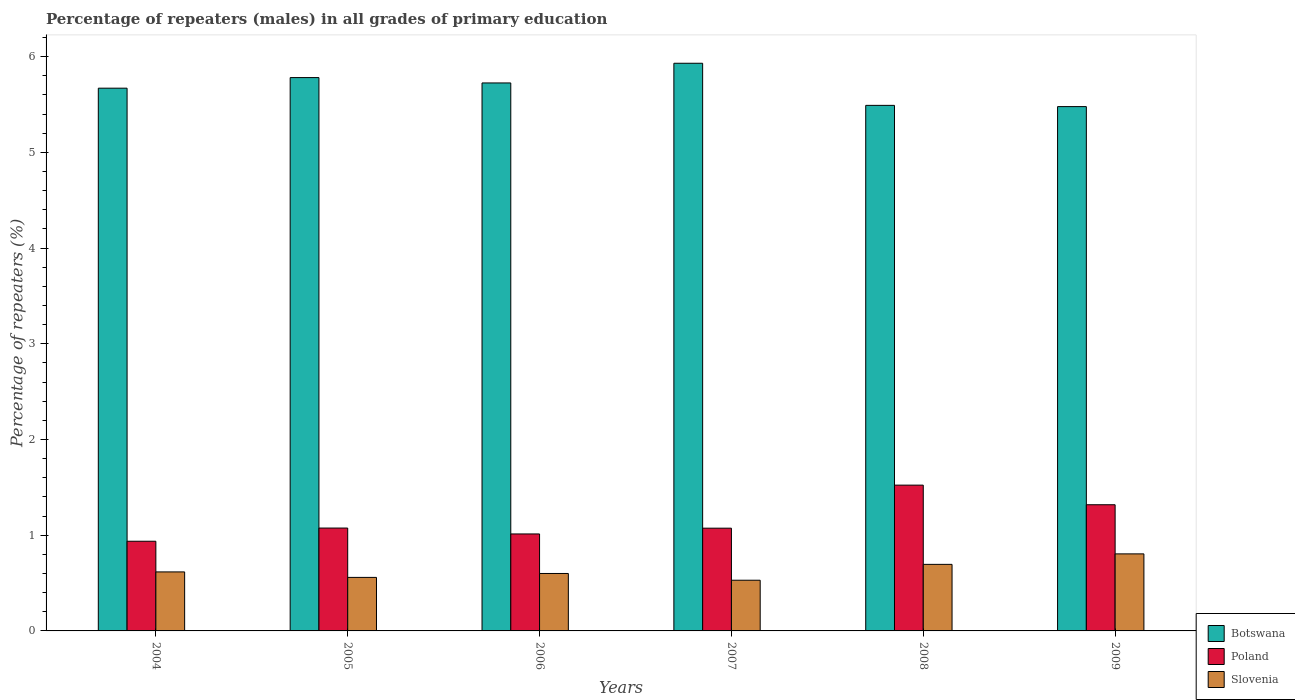How many different coloured bars are there?
Your response must be concise. 3. How many groups of bars are there?
Provide a succinct answer. 6. Are the number of bars on each tick of the X-axis equal?
Provide a succinct answer. Yes. How many bars are there on the 5th tick from the left?
Give a very brief answer. 3. How many bars are there on the 2nd tick from the right?
Offer a very short reply. 3. What is the label of the 1st group of bars from the left?
Ensure brevity in your answer.  2004. What is the percentage of repeaters (males) in Botswana in 2007?
Ensure brevity in your answer.  5.93. Across all years, what is the maximum percentage of repeaters (males) in Botswana?
Make the answer very short. 5.93. Across all years, what is the minimum percentage of repeaters (males) in Slovenia?
Your answer should be compact. 0.53. In which year was the percentage of repeaters (males) in Poland maximum?
Your answer should be compact. 2008. In which year was the percentage of repeaters (males) in Poland minimum?
Ensure brevity in your answer.  2004. What is the total percentage of repeaters (males) in Poland in the graph?
Your response must be concise. 6.94. What is the difference between the percentage of repeaters (males) in Botswana in 2004 and that in 2006?
Your answer should be very brief. -0.05. What is the difference between the percentage of repeaters (males) in Poland in 2009 and the percentage of repeaters (males) in Slovenia in 2006?
Make the answer very short. 0.72. What is the average percentage of repeaters (males) in Poland per year?
Your response must be concise. 1.16. In the year 2005, what is the difference between the percentage of repeaters (males) in Poland and percentage of repeaters (males) in Slovenia?
Offer a very short reply. 0.52. What is the ratio of the percentage of repeaters (males) in Slovenia in 2004 to that in 2009?
Give a very brief answer. 0.77. Is the percentage of repeaters (males) in Poland in 2007 less than that in 2008?
Ensure brevity in your answer.  Yes. What is the difference between the highest and the second highest percentage of repeaters (males) in Botswana?
Give a very brief answer. 0.15. What is the difference between the highest and the lowest percentage of repeaters (males) in Botswana?
Make the answer very short. 0.45. What does the 3rd bar from the left in 2007 represents?
Provide a succinct answer. Slovenia. What does the 3rd bar from the right in 2009 represents?
Offer a terse response. Botswana. Is it the case that in every year, the sum of the percentage of repeaters (males) in Slovenia and percentage of repeaters (males) in Poland is greater than the percentage of repeaters (males) in Botswana?
Your response must be concise. No. Are all the bars in the graph horizontal?
Ensure brevity in your answer.  No. How many years are there in the graph?
Offer a very short reply. 6. Does the graph contain any zero values?
Give a very brief answer. No. Does the graph contain grids?
Your answer should be compact. No. How many legend labels are there?
Ensure brevity in your answer.  3. What is the title of the graph?
Offer a very short reply. Percentage of repeaters (males) in all grades of primary education. Does "Chile" appear as one of the legend labels in the graph?
Your answer should be very brief. No. What is the label or title of the X-axis?
Offer a very short reply. Years. What is the label or title of the Y-axis?
Your answer should be very brief. Percentage of repeaters (%). What is the Percentage of repeaters (%) in Botswana in 2004?
Offer a terse response. 5.67. What is the Percentage of repeaters (%) in Poland in 2004?
Give a very brief answer. 0.94. What is the Percentage of repeaters (%) of Slovenia in 2004?
Your response must be concise. 0.62. What is the Percentage of repeaters (%) of Botswana in 2005?
Offer a very short reply. 5.78. What is the Percentage of repeaters (%) of Poland in 2005?
Provide a short and direct response. 1.07. What is the Percentage of repeaters (%) of Slovenia in 2005?
Provide a succinct answer. 0.56. What is the Percentage of repeaters (%) of Botswana in 2006?
Your response must be concise. 5.72. What is the Percentage of repeaters (%) in Poland in 2006?
Your response must be concise. 1.01. What is the Percentage of repeaters (%) of Slovenia in 2006?
Your response must be concise. 0.6. What is the Percentage of repeaters (%) of Botswana in 2007?
Your answer should be compact. 5.93. What is the Percentage of repeaters (%) in Poland in 2007?
Provide a succinct answer. 1.07. What is the Percentage of repeaters (%) of Slovenia in 2007?
Provide a short and direct response. 0.53. What is the Percentage of repeaters (%) of Botswana in 2008?
Provide a succinct answer. 5.49. What is the Percentage of repeaters (%) in Poland in 2008?
Keep it short and to the point. 1.52. What is the Percentage of repeaters (%) in Slovenia in 2008?
Provide a succinct answer. 0.7. What is the Percentage of repeaters (%) of Botswana in 2009?
Give a very brief answer. 5.48. What is the Percentage of repeaters (%) of Poland in 2009?
Keep it short and to the point. 1.32. What is the Percentage of repeaters (%) of Slovenia in 2009?
Give a very brief answer. 0.8. Across all years, what is the maximum Percentage of repeaters (%) of Botswana?
Keep it short and to the point. 5.93. Across all years, what is the maximum Percentage of repeaters (%) of Poland?
Provide a succinct answer. 1.52. Across all years, what is the maximum Percentage of repeaters (%) of Slovenia?
Your answer should be compact. 0.8. Across all years, what is the minimum Percentage of repeaters (%) of Botswana?
Offer a terse response. 5.48. Across all years, what is the minimum Percentage of repeaters (%) of Poland?
Your response must be concise. 0.94. Across all years, what is the minimum Percentage of repeaters (%) in Slovenia?
Your answer should be very brief. 0.53. What is the total Percentage of repeaters (%) of Botswana in the graph?
Offer a very short reply. 34.07. What is the total Percentage of repeaters (%) of Poland in the graph?
Your answer should be very brief. 6.94. What is the total Percentage of repeaters (%) of Slovenia in the graph?
Ensure brevity in your answer.  3.81. What is the difference between the Percentage of repeaters (%) of Botswana in 2004 and that in 2005?
Your answer should be compact. -0.11. What is the difference between the Percentage of repeaters (%) in Poland in 2004 and that in 2005?
Make the answer very short. -0.14. What is the difference between the Percentage of repeaters (%) in Slovenia in 2004 and that in 2005?
Provide a succinct answer. 0.06. What is the difference between the Percentage of repeaters (%) of Botswana in 2004 and that in 2006?
Provide a short and direct response. -0.05. What is the difference between the Percentage of repeaters (%) of Poland in 2004 and that in 2006?
Offer a terse response. -0.08. What is the difference between the Percentage of repeaters (%) in Slovenia in 2004 and that in 2006?
Give a very brief answer. 0.02. What is the difference between the Percentage of repeaters (%) of Botswana in 2004 and that in 2007?
Your response must be concise. -0.26. What is the difference between the Percentage of repeaters (%) of Poland in 2004 and that in 2007?
Your answer should be very brief. -0.14. What is the difference between the Percentage of repeaters (%) in Slovenia in 2004 and that in 2007?
Your response must be concise. 0.09. What is the difference between the Percentage of repeaters (%) of Botswana in 2004 and that in 2008?
Offer a terse response. 0.18. What is the difference between the Percentage of repeaters (%) of Poland in 2004 and that in 2008?
Ensure brevity in your answer.  -0.59. What is the difference between the Percentage of repeaters (%) in Slovenia in 2004 and that in 2008?
Ensure brevity in your answer.  -0.08. What is the difference between the Percentage of repeaters (%) of Botswana in 2004 and that in 2009?
Offer a terse response. 0.19. What is the difference between the Percentage of repeaters (%) in Poland in 2004 and that in 2009?
Provide a short and direct response. -0.38. What is the difference between the Percentage of repeaters (%) in Slovenia in 2004 and that in 2009?
Your answer should be compact. -0.19. What is the difference between the Percentage of repeaters (%) in Botswana in 2005 and that in 2006?
Your answer should be very brief. 0.06. What is the difference between the Percentage of repeaters (%) of Poland in 2005 and that in 2006?
Provide a short and direct response. 0.06. What is the difference between the Percentage of repeaters (%) of Slovenia in 2005 and that in 2006?
Offer a terse response. -0.04. What is the difference between the Percentage of repeaters (%) in Botswana in 2005 and that in 2007?
Offer a terse response. -0.15. What is the difference between the Percentage of repeaters (%) in Poland in 2005 and that in 2007?
Your answer should be very brief. 0. What is the difference between the Percentage of repeaters (%) of Slovenia in 2005 and that in 2007?
Give a very brief answer. 0.03. What is the difference between the Percentage of repeaters (%) of Botswana in 2005 and that in 2008?
Offer a very short reply. 0.29. What is the difference between the Percentage of repeaters (%) in Poland in 2005 and that in 2008?
Offer a terse response. -0.45. What is the difference between the Percentage of repeaters (%) of Slovenia in 2005 and that in 2008?
Offer a terse response. -0.14. What is the difference between the Percentage of repeaters (%) in Botswana in 2005 and that in 2009?
Offer a terse response. 0.3. What is the difference between the Percentage of repeaters (%) in Poland in 2005 and that in 2009?
Offer a terse response. -0.24. What is the difference between the Percentage of repeaters (%) of Slovenia in 2005 and that in 2009?
Provide a short and direct response. -0.25. What is the difference between the Percentage of repeaters (%) in Botswana in 2006 and that in 2007?
Offer a very short reply. -0.21. What is the difference between the Percentage of repeaters (%) in Poland in 2006 and that in 2007?
Your answer should be very brief. -0.06. What is the difference between the Percentage of repeaters (%) in Slovenia in 2006 and that in 2007?
Give a very brief answer. 0.07. What is the difference between the Percentage of repeaters (%) of Botswana in 2006 and that in 2008?
Provide a succinct answer. 0.23. What is the difference between the Percentage of repeaters (%) in Poland in 2006 and that in 2008?
Make the answer very short. -0.51. What is the difference between the Percentage of repeaters (%) of Slovenia in 2006 and that in 2008?
Offer a very short reply. -0.1. What is the difference between the Percentage of repeaters (%) in Botswana in 2006 and that in 2009?
Offer a very short reply. 0.25. What is the difference between the Percentage of repeaters (%) in Poland in 2006 and that in 2009?
Ensure brevity in your answer.  -0.31. What is the difference between the Percentage of repeaters (%) in Slovenia in 2006 and that in 2009?
Your answer should be very brief. -0.2. What is the difference between the Percentage of repeaters (%) of Botswana in 2007 and that in 2008?
Provide a succinct answer. 0.44. What is the difference between the Percentage of repeaters (%) of Poland in 2007 and that in 2008?
Give a very brief answer. -0.45. What is the difference between the Percentage of repeaters (%) of Slovenia in 2007 and that in 2008?
Give a very brief answer. -0.17. What is the difference between the Percentage of repeaters (%) in Botswana in 2007 and that in 2009?
Offer a terse response. 0.45. What is the difference between the Percentage of repeaters (%) in Poland in 2007 and that in 2009?
Your response must be concise. -0.24. What is the difference between the Percentage of repeaters (%) in Slovenia in 2007 and that in 2009?
Ensure brevity in your answer.  -0.28. What is the difference between the Percentage of repeaters (%) of Botswana in 2008 and that in 2009?
Your answer should be very brief. 0.01. What is the difference between the Percentage of repeaters (%) of Poland in 2008 and that in 2009?
Offer a terse response. 0.2. What is the difference between the Percentage of repeaters (%) in Slovenia in 2008 and that in 2009?
Your answer should be compact. -0.11. What is the difference between the Percentage of repeaters (%) in Botswana in 2004 and the Percentage of repeaters (%) in Poland in 2005?
Ensure brevity in your answer.  4.6. What is the difference between the Percentage of repeaters (%) in Botswana in 2004 and the Percentage of repeaters (%) in Slovenia in 2005?
Keep it short and to the point. 5.11. What is the difference between the Percentage of repeaters (%) in Poland in 2004 and the Percentage of repeaters (%) in Slovenia in 2005?
Keep it short and to the point. 0.38. What is the difference between the Percentage of repeaters (%) in Botswana in 2004 and the Percentage of repeaters (%) in Poland in 2006?
Your answer should be very brief. 4.66. What is the difference between the Percentage of repeaters (%) of Botswana in 2004 and the Percentage of repeaters (%) of Slovenia in 2006?
Keep it short and to the point. 5.07. What is the difference between the Percentage of repeaters (%) in Poland in 2004 and the Percentage of repeaters (%) in Slovenia in 2006?
Offer a very short reply. 0.34. What is the difference between the Percentage of repeaters (%) in Botswana in 2004 and the Percentage of repeaters (%) in Poland in 2007?
Give a very brief answer. 4.6. What is the difference between the Percentage of repeaters (%) of Botswana in 2004 and the Percentage of repeaters (%) of Slovenia in 2007?
Make the answer very short. 5.14. What is the difference between the Percentage of repeaters (%) of Poland in 2004 and the Percentage of repeaters (%) of Slovenia in 2007?
Keep it short and to the point. 0.41. What is the difference between the Percentage of repeaters (%) of Botswana in 2004 and the Percentage of repeaters (%) of Poland in 2008?
Your answer should be very brief. 4.15. What is the difference between the Percentage of repeaters (%) in Botswana in 2004 and the Percentage of repeaters (%) in Slovenia in 2008?
Offer a terse response. 4.97. What is the difference between the Percentage of repeaters (%) of Poland in 2004 and the Percentage of repeaters (%) of Slovenia in 2008?
Provide a short and direct response. 0.24. What is the difference between the Percentage of repeaters (%) of Botswana in 2004 and the Percentage of repeaters (%) of Poland in 2009?
Make the answer very short. 4.35. What is the difference between the Percentage of repeaters (%) of Botswana in 2004 and the Percentage of repeaters (%) of Slovenia in 2009?
Provide a short and direct response. 4.87. What is the difference between the Percentage of repeaters (%) of Poland in 2004 and the Percentage of repeaters (%) of Slovenia in 2009?
Your answer should be very brief. 0.13. What is the difference between the Percentage of repeaters (%) of Botswana in 2005 and the Percentage of repeaters (%) of Poland in 2006?
Give a very brief answer. 4.77. What is the difference between the Percentage of repeaters (%) of Botswana in 2005 and the Percentage of repeaters (%) of Slovenia in 2006?
Provide a short and direct response. 5.18. What is the difference between the Percentage of repeaters (%) in Poland in 2005 and the Percentage of repeaters (%) in Slovenia in 2006?
Offer a very short reply. 0.47. What is the difference between the Percentage of repeaters (%) of Botswana in 2005 and the Percentage of repeaters (%) of Poland in 2007?
Provide a short and direct response. 4.71. What is the difference between the Percentage of repeaters (%) of Botswana in 2005 and the Percentage of repeaters (%) of Slovenia in 2007?
Your response must be concise. 5.25. What is the difference between the Percentage of repeaters (%) of Poland in 2005 and the Percentage of repeaters (%) of Slovenia in 2007?
Give a very brief answer. 0.55. What is the difference between the Percentage of repeaters (%) in Botswana in 2005 and the Percentage of repeaters (%) in Poland in 2008?
Give a very brief answer. 4.26. What is the difference between the Percentage of repeaters (%) in Botswana in 2005 and the Percentage of repeaters (%) in Slovenia in 2008?
Make the answer very short. 5.09. What is the difference between the Percentage of repeaters (%) of Poland in 2005 and the Percentage of repeaters (%) of Slovenia in 2008?
Offer a very short reply. 0.38. What is the difference between the Percentage of repeaters (%) in Botswana in 2005 and the Percentage of repeaters (%) in Poland in 2009?
Ensure brevity in your answer.  4.46. What is the difference between the Percentage of repeaters (%) of Botswana in 2005 and the Percentage of repeaters (%) of Slovenia in 2009?
Offer a terse response. 4.98. What is the difference between the Percentage of repeaters (%) in Poland in 2005 and the Percentage of repeaters (%) in Slovenia in 2009?
Offer a terse response. 0.27. What is the difference between the Percentage of repeaters (%) in Botswana in 2006 and the Percentage of repeaters (%) in Poland in 2007?
Your response must be concise. 4.65. What is the difference between the Percentage of repeaters (%) of Botswana in 2006 and the Percentage of repeaters (%) of Slovenia in 2007?
Keep it short and to the point. 5.2. What is the difference between the Percentage of repeaters (%) of Poland in 2006 and the Percentage of repeaters (%) of Slovenia in 2007?
Give a very brief answer. 0.48. What is the difference between the Percentage of repeaters (%) of Botswana in 2006 and the Percentage of repeaters (%) of Poland in 2008?
Offer a very short reply. 4.2. What is the difference between the Percentage of repeaters (%) of Botswana in 2006 and the Percentage of repeaters (%) of Slovenia in 2008?
Your answer should be very brief. 5.03. What is the difference between the Percentage of repeaters (%) of Poland in 2006 and the Percentage of repeaters (%) of Slovenia in 2008?
Make the answer very short. 0.32. What is the difference between the Percentage of repeaters (%) in Botswana in 2006 and the Percentage of repeaters (%) in Poland in 2009?
Your answer should be very brief. 4.41. What is the difference between the Percentage of repeaters (%) in Botswana in 2006 and the Percentage of repeaters (%) in Slovenia in 2009?
Keep it short and to the point. 4.92. What is the difference between the Percentage of repeaters (%) in Poland in 2006 and the Percentage of repeaters (%) in Slovenia in 2009?
Give a very brief answer. 0.21. What is the difference between the Percentage of repeaters (%) in Botswana in 2007 and the Percentage of repeaters (%) in Poland in 2008?
Your answer should be very brief. 4.41. What is the difference between the Percentage of repeaters (%) in Botswana in 2007 and the Percentage of repeaters (%) in Slovenia in 2008?
Give a very brief answer. 5.24. What is the difference between the Percentage of repeaters (%) in Poland in 2007 and the Percentage of repeaters (%) in Slovenia in 2008?
Your answer should be very brief. 0.38. What is the difference between the Percentage of repeaters (%) of Botswana in 2007 and the Percentage of repeaters (%) of Poland in 2009?
Provide a short and direct response. 4.61. What is the difference between the Percentage of repeaters (%) in Botswana in 2007 and the Percentage of repeaters (%) in Slovenia in 2009?
Keep it short and to the point. 5.13. What is the difference between the Percentage of repeaters (%) of Poland in 2007 and the Percentage of repeaters (%) of Slovenia in 2009?
Make the answer very short. 0.27. What is the difference between the Percentage of repeaters (%) of Botswana in 2008 and the Percentage of repeaters (%) of Poland in 2009?
Provide a succinct answer. 4.17. What is the difference between the Percentage of repeaters (%) in Botswana in 2008 and the Percentage of repeaters (%) in Slovenia in 2009?
Provide a succinct answer. 4.69. What is the difference between the Percentage of repeaters (%) in Poland in 2008 and the Percentage of repeaters (%) in Slovenia in 2009?
Offer a very short reply. 0.72. What is the average Percentage of repeaters (%) in Botswana per year?
Keep it short and to the point. 5.68. What is the average Percentage of repeaters (%) in Poland per year?
Provide a succinct answer. 1.16. What is the average Percentage of repeaters (%) in Slovenia per year?
Provide a short and direct response. 0.63. In the year 2004, what is the difference between the Percentage of repeaters (%) of Botswana and Percentage of repeaters (%) of Poland?
Give a very brief answer. 4.73. In the year 2004, what is the difference between the Percentage of repeaters (%) in Botswana and Percentage of repeaters (%) in Slovenia?
Provide a short and direct response. 5.05. In the year 2004, what is the difference between the Percentage of repeaters (%) of Poland and Percentage of repeaters (%) of Slovenia?
Your answer should be compact. 0.32. In the year 2005, what is the difference between the Percentage of repeaters (%) in Botswana and Percentage of repeaters (%) in Poland?
Your answer should be compact. 4.71. In the year 2005, what is the difference between the Percentage of repeaters (%) in Botswana and Percentage of repeaters (%) in Slovenia?
Give a very brief answer. 5.22. In the year 2005, what is the difference between the Percentage of repeaters (%) in Poland and Percentage of repeaters (%) in Slovenia?
Your response must be concise. 0.52. In the year 2006, what is the difference between the Percentage of repeaters (%) in Botswana and Percentage of repeaters (%) in Poland?
Offer a terse response. 4.71. In the year 2006, what is the difference between the Percentage of repeaters (%) of Botswana and Percentage of repeaters (%) of Slovenia?
Give a very brief answer. 5.12. In the year 2006, what is the difference between the Percentage of repeaters (%) of Poland and Percentage of repeaters (%) of Slovenia?
Provide a succinct answer. 0.41. In the year 2007, what is the difference between the Percentage of repeaters (%) in Botswana and Percentage of repeaters (%) in Poland?
Offer a terse response. 4.86. In the year 2007, what is the difference between the Percentage of repeaters (%) in Botswana and Percentage of repeaters (%) in Slovenia?
Keep it short and to the point. 5.4. In the year 2007, what is the difference between the Percentage of repeaters (%) in Poland and Percentage of repeaters (%) in Slovenia?
Make the answer very short. 0.54. In the year 2008, what is the difference between the Percentage of repeaters (%) in Botswana and Percentage of repeaters (%) in Poland?
Offer a very short reply. 3.97. In the year 2008, what is the difference between the Percentage of repeaters (%) in Botswana and Percentage of repeaters (%) in Slovenia?
Your answer should be compact. 4.8. In the year 2008, what is the difference between the Percentage of repeaters (%) of Poland and Percentage of repeaters (%) of Slovenia?
Keep it short and to the point. 0.83. In the year 2009, what is the difference between the Percentage of repeaters (%) of Botswana and Percentage of repeaters (%) of Poland?
Offer a terse response. 4.16. In the year 2009, what is the difference between the Percentage of repeaters (%) of Botswana and Percentage of repeaters (%) of Slovenia?
Keep it short and to the point. 4.67. In the year 2009, what is the difference between the Percentage of repeaters (%) of Poland and Percentage of repeaters (%) of Slovenia?
Your response must be concise. 0.51. What is the ratio of the Percentage of repeaters (%) of Botswana in 2004 to that in 2005?
Offer a terse response. 0.98. What is the ratio of the Percentage of repeaters (%) in Poland in 2004 to that in 2005?
Give a very brief answer. 0.87. What is the ratio of the Percentage of repeaters (%) of Slovenia in 2004 to that in 2005?
Your response must be concise. 1.1. What is the ratio of the Percentage of repeaters (%) in Botswana in 2004 to that in 2006?
Provide a succinct answer. 0.99. What is the ratio of the Percentage of repeaters (%) in Poland in 2004 to that in 2006?
Provide a succinct answer. 0.92. What is the ratio of the Percentage of repeaters (%) of Slovenia in 2004 to that in 2006?
Ensure brevity in your answer.  1.03. What is the ratio of the Percentage of repeaters (%) of Botswana in 2004 to that in 2007?
Provide a succinct answer. 0.96. What is the ratio of the Percentage of repeaters (%) in Poland in 2004 to that in 2007?
Your answer should be very brief. 0.87. What is the ratio of the Percentage of repeaters (%) in Slovenia in 2004 to that in 2007?
Offer a terse response. 1.16. What is the ratio of the Percentage of repeaters (%) in Botswana in 2004 to that in 2008?
Give a very brief answer. 1.03. What is the ratio of the Percentage of repeaters (%) of Poland in 2004 to that in 2008?
Provide a short and direct response. 0.62. What is the ratio of the Percentage of repeaters (%) in Slovenia in 2004 to that in 2008?
Provide a succinct answer. 0.89. What is the ratio of the Percentage of repeaters (%) in Botswana in 2004 to that in 2009?
Give a very brief answer. 1.04. What is the ratio of the Percentage of repeaters (%) in Poland in 2004 to that in 2009?
Give a very brief answer. 0.71. What is the ratio of the Percentage of repeaters (%) of Slovenia in 2004 to that in 2009?
Your answer should be compact. 0.77. What is the ratio of the Percentage of repeaters (%) in Botswana in 2005 to that in 2006?
Make the answer very short. 1.01. What is the ratio of the Percentage of repeaters (%) of Poland in 2005 to that in 2006?
Keep it short and to the point. 1.06. What is the ratio of the Percentage of repeaters (%) of Slovenia in 2005 to that in 2006?
Your answer should be very brief. 0.93. What is the ratio of the Percentage of repeaters (%) in Botswana in 2005 to that in 2007?
Offer a very short reply. 0.97. What is the ratio of the Percentage of repeaters (%) in Poland in 2005 to that in 2007?
Your response must be concise. 1. What is the ratio of the Percentage of repeaters (%) in Slovenia in 2005 to that in 2007?
Your answer should be compact. 1.06. What is the ratio of the Percentage of repeaters (%) of Botswana in 2005 to that in 2008?
Keep it short and to the point. 1.05. What is the ratio of the Percentage of repeaters (%) of Poland in 2005 to that in 2008?
Your answer should be very brief. 0.71. What is the ratio of the Percentage of repeaters (%) of Slovenia in 2005 to that in 2008?
Your answer should be very brief. 0.8. What is the ratio of the Percentage of repeaters (%) of Botswana in 2005 to that in 2009?
Provide a short and direct response. 1.06. What is the ratio of the Percentage of repeaters (%) in Poland in 2005 to that in 2009?
Give a very brief answer. 0.82. What is the ratio of the Percentage of repeaters (%) in Slovenia in 2005 to that in 2009?
Offer a very short reply. 0.69. What is the ratio of the Percentage of repeaters (%) of Botswana in 2006 to that in 2007?
Your response must be concise. 0.97. What is the ratio of the Percentage of repeaters (%) of Poland in 2006 to that in 2007?
Your response must be concise. 0.94. What is the ratio of the Percentage of repeaters (%) in Slovenia in 2006 to that in 2007?
Your answer should be compact. 1.13. What is the ratio of the Percentage of repeaters (%) in Botswana in 2006 to that in 2008?
Your answer should be compact. 1.04. What is the ratio of the Percentage of repeaters (%) in Poland in 2006 to that in 2008?
Offer a very short reply. 0.67. What is the ratio of the Percentage of repeaters (%) of Slovenia in 2006 to that in 2008?
Your answer should be very brief. 0.86. What is the ratio of the Percentage of repeaters (%) of Botswana in 2006 to that in 2009?
Ensure brevity in your answer.  1.05. What is the ratio of the Percentage of repeaters (%) in Poland in 2006 to that in 2009?
Keep it short and to the point. 0.77. What is the ratio of the Percentage of repeaters (%) in Slovenia in 2006 to that in 2009?
Ensure brevity in your answer.  0.75. What is the ratio of the Percentage of repeaters (%) of Botswana in 2007 to that in 2008?
Give a very brief answer. 1.08. What is the ratio of the Percentage of repeaters (%) in Poland in 2007 to that in 2008?
Keep it short and to the point. 0.7. What is the ratio of the Percentage of repeaters (%) in Slovenia in 2007 to that in 2008?
Make the answer very short. 0.76. What is the ratio of the Percentage of repeaters (%) of Botswana in 2007 to that in 2009?
Keep it short and to the point. 1.08. What is the ratio of the Percentage of repeaters (%) in Poland in 2007 to that in 2009?
Your response must be concise. 0.81. What is the ratio of the Percentage of repeaters (%) in Slovenia in 2007 to that in 2009?
Offer a very short reply. 0.66. What is the ratio of the Percentage of repeaters (%) in Botswana in 2008 to that in 2009?
Your answer should be compact. 1. What is the ratio of the Percentage of repeaters (%) in Poland in 2008 to that in 2009?
Your answer should be very brief. 1.16. What is the ratio of the Percentage of repeaters (%) in Slovenia in 2008 to that in 2009?
Give a very brief answer. 0.86. What is the difference between the highest and the second highest Percentage of repeaters (%) of Botswana?
Your answer should be very brief. 0.15. What is the difference between the highest and the second highest Percentage of repeaters (%) of Poland?
Provide a succinct answer. 0.2. What is the difference between the highest and the second highest Percentage of repeaters (%) in Slovenia?
Provide a short and direct response. 0.11. What is the difference between the highest and the lowest Percentage of repeaters (%) of Botswana?
Provide a succinct answer. 0.45. What is the difference between the highest and the lowest Percentage of repeaters (%) of Poland?
Offer a very short reply. 0.59. What is the difference between the highest and the lowest Percentage of repeaters (%) of Slovenia?
Make the answer very short. 0.28. 